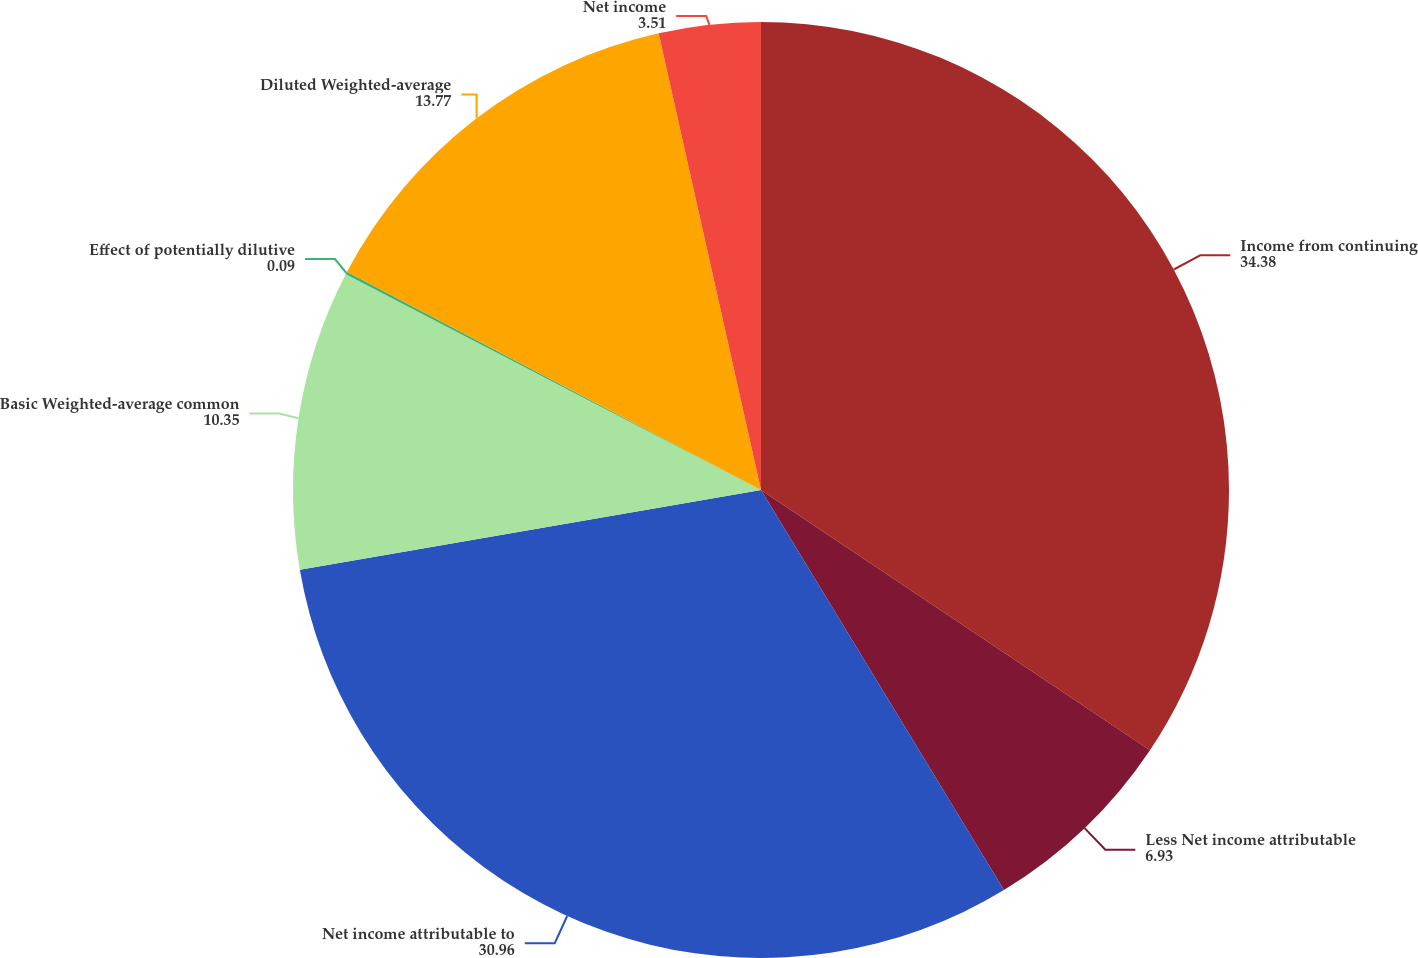Convert chart. <chart><loc_0><loc_0><loc_500><loc_500><pie_chart><fcel>Income from continuing<fcel>Less Net income attributable<fcel>Net income attributable to<fcel>Basic Weighted-average common<fcel>Effect of potentially dilutive<fcel>Diluted Weighted-average<fcel>Net income<nl><fcel>34.38%<fcel>6.93%<fcel>30.96%<fcel>10.35%<fcel>0.09%<fcel>13.77%<fcel>3.51%<nl></chart> 